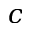Convert formula to latex. <formula><loc_0><loc_0><loc_500><loc_500>c</formula> 